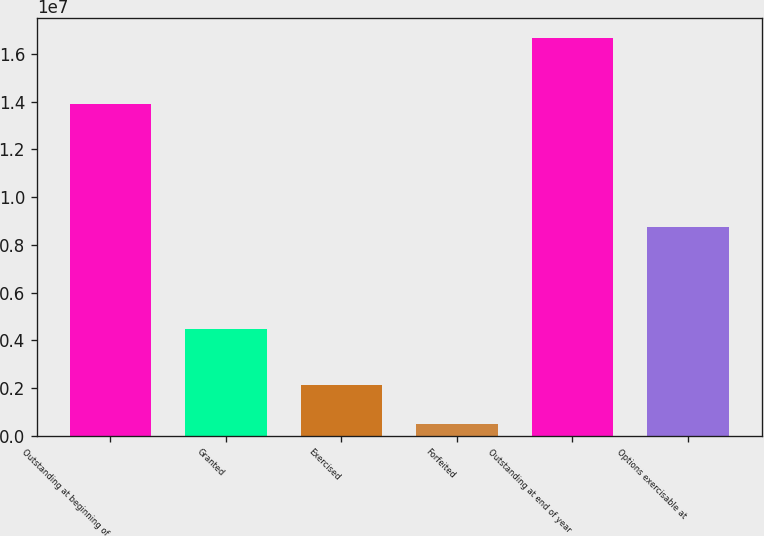<chart> <loc_0><loc_0><loc_500><loc_500><bar_chart><fcel>Outstanding at beginning of<fcel>Granted<fcel>Exercised<fcel>Forfeited<fcel>Outstanding at end of year<fcel>Options exercisable at<nl><fcel>1.38891e+07<fcel>4.46849e+06<fcel>2.10776e+06<fcel>489550<fcel>1.66716e+07<fcel>8.7522e+06<nl></chart> 